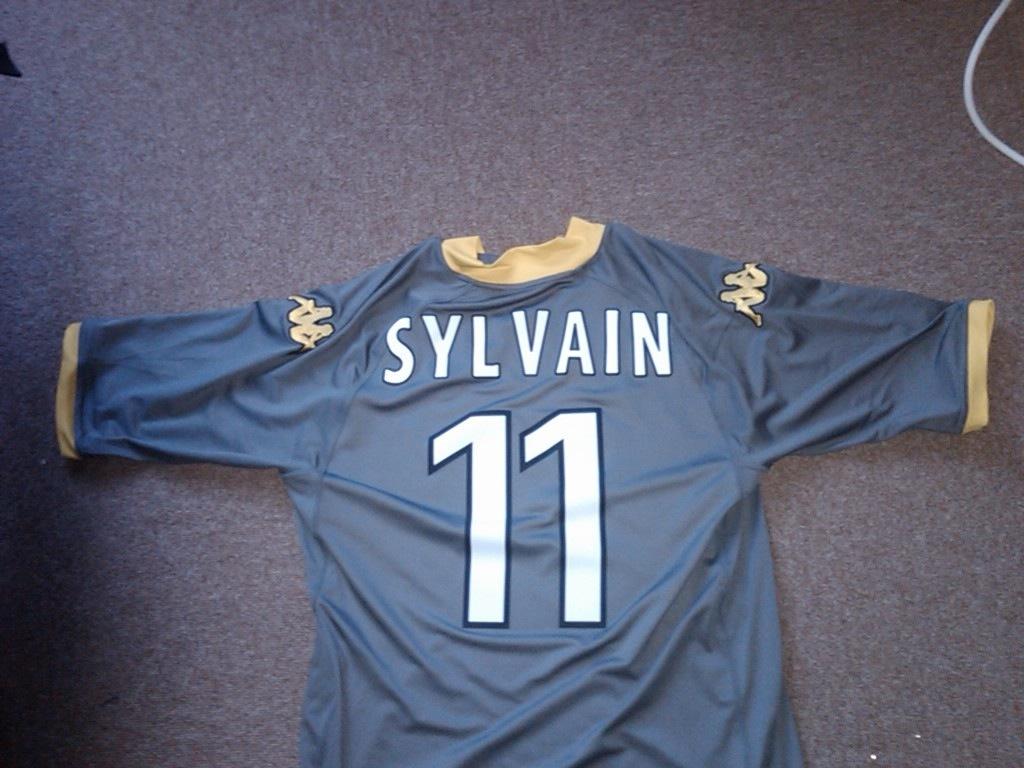What is the number on the jersey?
Provide a short and direct response. 11. Whos name is on the jersey?
Keep it short and to the point. Sylvain. 